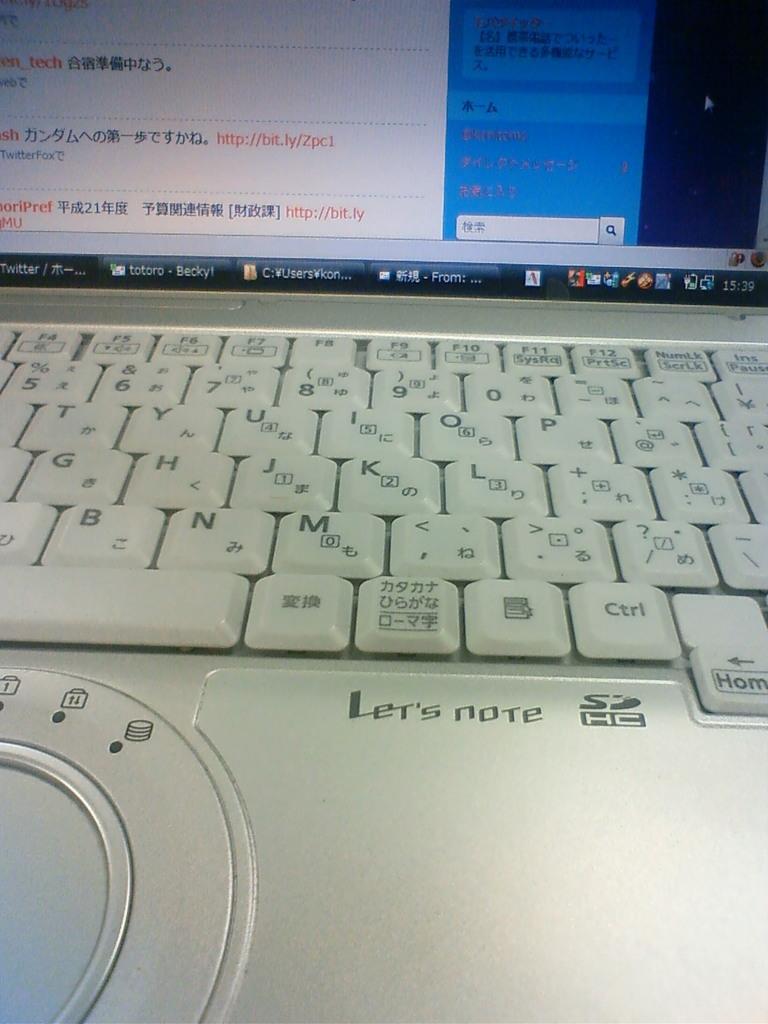Which key is above the sd hc logo?
Provide a short and direct response. Ctrl. What is the name of the laptop?
Provide a short and direct response. Let's note. 